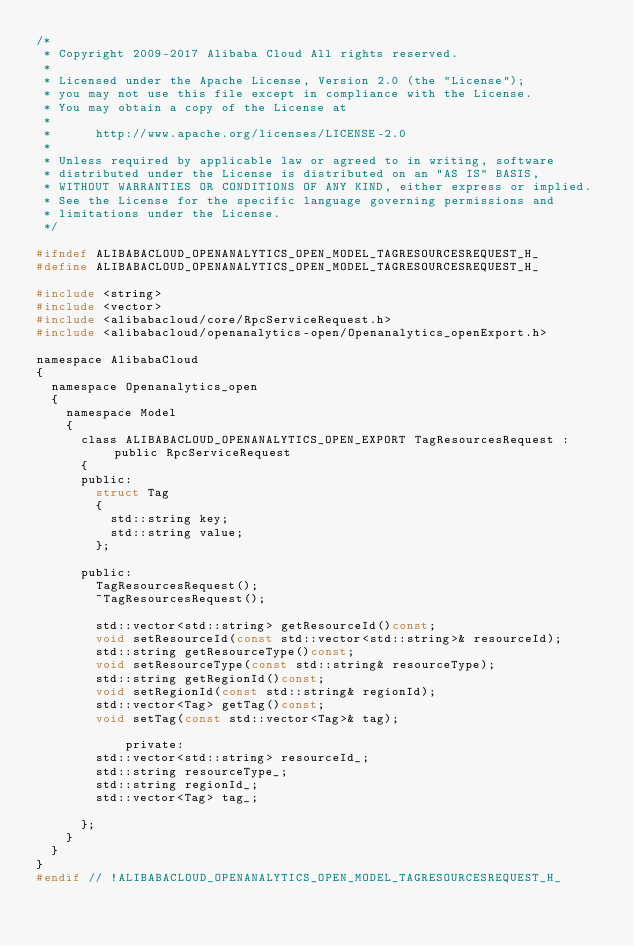Convert code to text. <code><loc_0><loc_0><loc_500><loc_500><_C_>/*
 * Copyright 2009-2017 Alibaba Cloud All rights reserved.
 * 
 * Licensed under the Apache License, Version 2.0 (the "License");
 * you may not use this file except in compliance with the License.
 * You may obtain a copy of the License at
 * 
 *      http://www.apache.org/licenses/LICENSE-2.0
 * 
 * Unless required by applicable law or agreed to in writing, software
 * distributed under the License is distributed on an "AS IS" BASIS,
 * WITHOUT WARRANTIES OR CONDITIONS OF ANY KIND, either express or implied.
 * See the License for the specific language governing permissions and
 * limitations under the License.
 */

#ifndef ALIBABACLOUD_OPENANALYTICS_OPEN_MODEL_TAGRESOURCESREQUEST_H_
#define ALIBABACLOUD_OPENANALYTICS_OPEN_MODEL_TAGRESOURCESREQUEST_H_

#include <string>
#include <vector>
#include <alibabacloud/core/RpcServiceRequest.h>
#include <alibabacloud/openanalytics-open/Openanalytics_openExport.h>

namespace AlibabaCloud
{
	namespace Openanalytics_open
	{
		namespace Model
		{
			class ALIBABACLOUD_OPENANALYTICS_OPEN_EXPORT TagResourcesRequest : public RpcServiceRequest
			{
			public:
				struct Tag
				{
					std::string key;
					std::string value;
				};

			public:
				TagResourcesRequest();
				~TagResourcesRequest();

				std::vector<std::string> getResourceId()const;
				void setResourceId(const std::vector<std::string>& resourceId);
				std::string getResourceType()const;
				void setResourceType(const std::string& resourceType);
				std::string getRegionId()const;
				void setRegionId(const std::string& regionId);
				std::vector<Tag> getTag()const;
				void setTag(const std::vector<Tag>& tag);

            private:
				std::vector<std::string> resourceId_;
				std::string resourceType_;
				std::string regionId_;
				std::vector<Tag> tag_;

			};
		}
	}
}
#endif // !ALIBABACLOUD_OPENANALYTICS_OPEN_MODEL_TAGRESOURCESREQUEST_H_</code> 